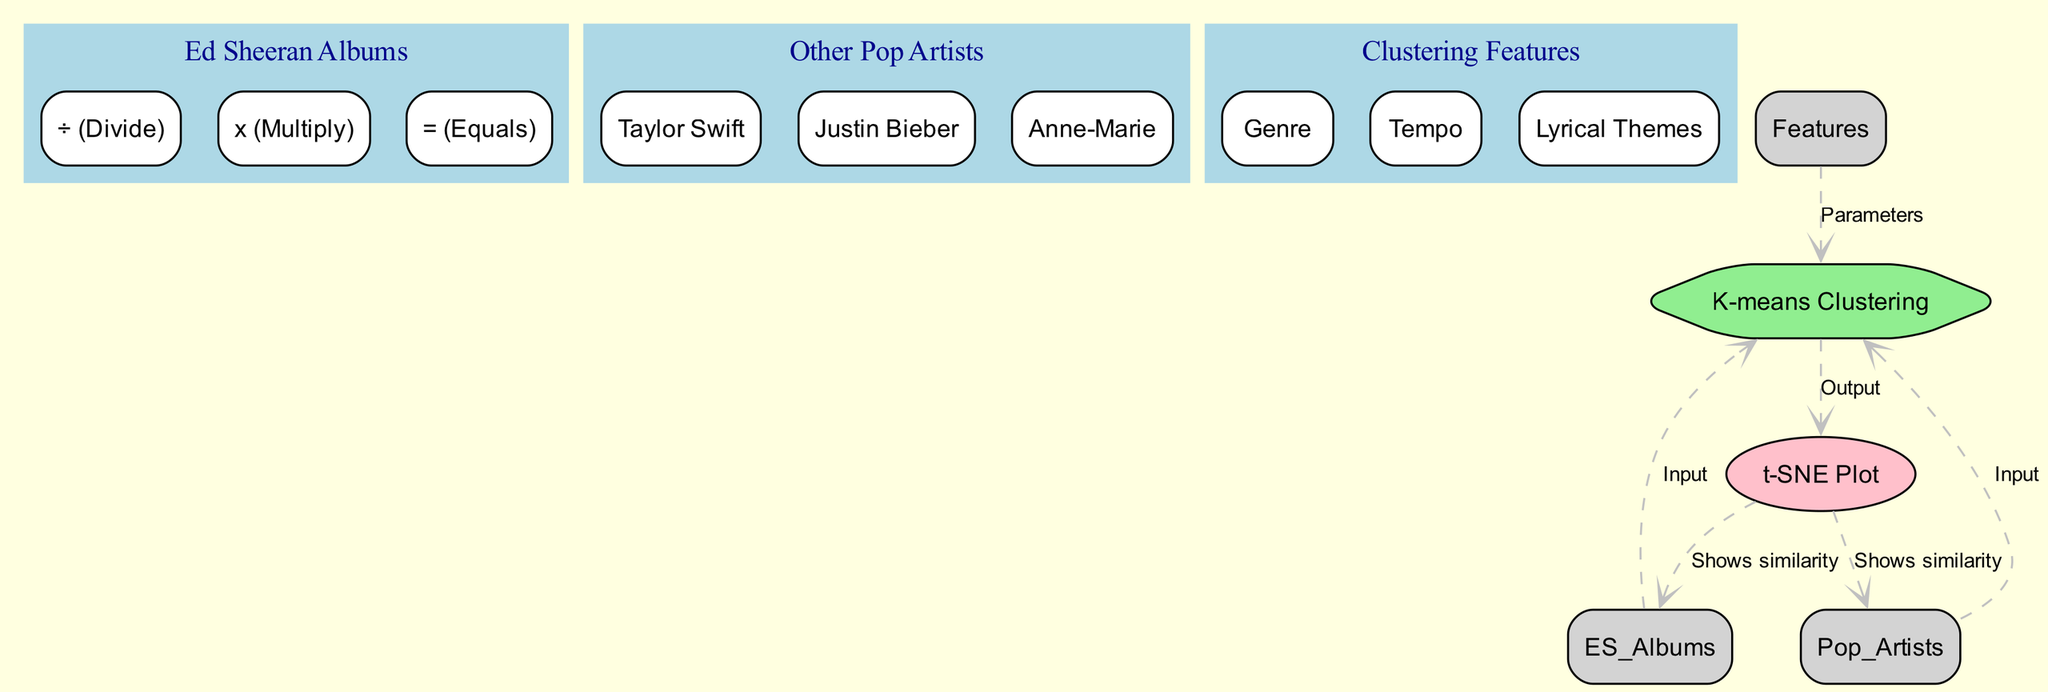What type of algorithm is used in this diagram? The algorithm node is labeled "K-means Clustering," which indicates the type of algorithm employed in this diagram for the clustering task.
Answer: K-means Clustering How many Ed Sheeran albums are listed in the diagram? There are three children nodes under the "Ed Sheeran Albums" node: "Divide," "Multiply," and "Equals." Thus, the total number of Ed Sheeran albums listed is three.
Answer: Three Which node shows similarity to Ed Sheeran's albums? The edge leading from "Visualization" to "ES_Albums" is labeled "Shows similarity," indicating that this node is responsible for visualizing similarity to Ed Sheeran's albums.
Answer: Visualization What features are used as parameters for the clustering algorithm? The "Clustering Features" node has three children: "Genre," "Tempo," and "Lyrical Themes," which are the features used as parameters for the clustering algorithm.
Answer: Genre, Tempo, Lyrical Themes How many edges are connected to the K-means Clustering node? The K-means Clustering node has four edges connected to it, indicating multiple inputs and outputs: two inputs from "Ed Sheeran Albums" and "Pop Artists," and two outputs to "Visualization."
Answer: Four Which pop artist is included in this diagram? The "Pop Artists" node lists three children, including "Taylor Swift," which is one of the pop artists included in this diagram.
Answer: Taylor Swift What is the output of the K-means Clustering algorithm? The edge leading to the "Visualization" node from the "Algorithm" node indicates that the output of the K-means Clustering algorithm is visualized in this node.
Answer: Visualization How many children does the "Features" node have? The "Features" node has three children: "Genre," "Tempo," and "Lyrical Themes," indicating the number of clustering features used.
Answer: Three Which artist is closest to Ed Sheeran's album "Equals" in the diagram? The diagram does not explicitly state which artist is closest to "Equals," as it visualizes similarities generally rather than specific closeness. Hence, this question cannot be answered with a node label directly.
Answer: Not specified 